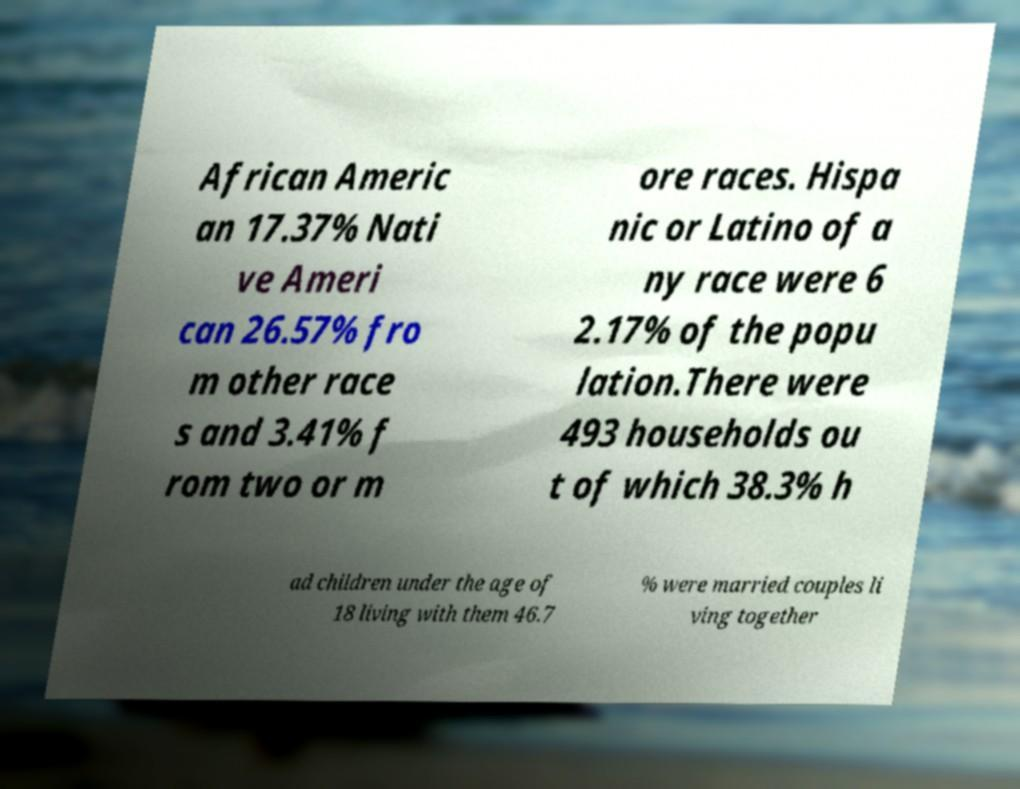Please read and relay the text visible in this image. What does it say? African Americ an 17.37% Nati ve Ameri can 26.57% fro m other race s and 3.41% f rom two or m ore races. Hispa nic or Latino of a ny race were 6 2.17% of the popu lation.There were 493 households ou t of which 38.3% h ad children under the age of 18 living with them 46.7 % were married couples li ving together 